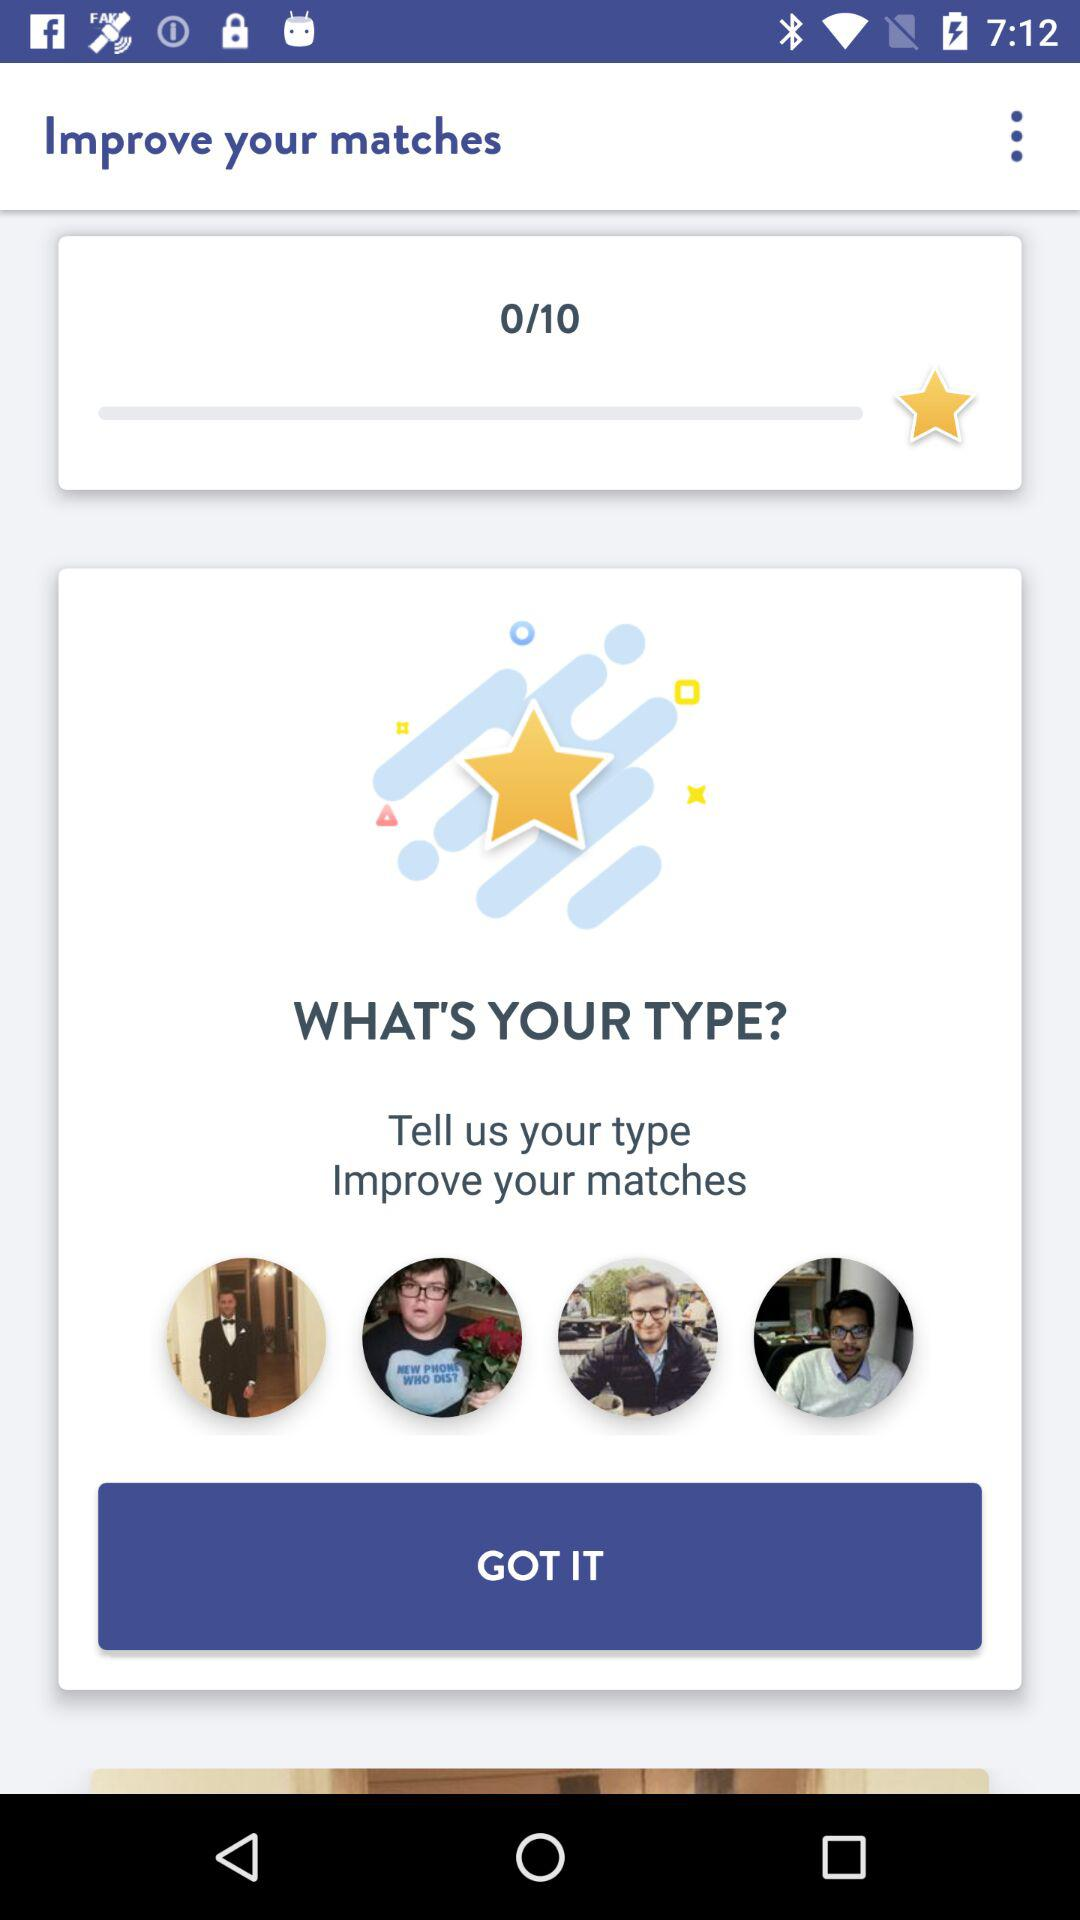What's the total number of stars needed to get the perfect match? The total number of stars needed is 10. 